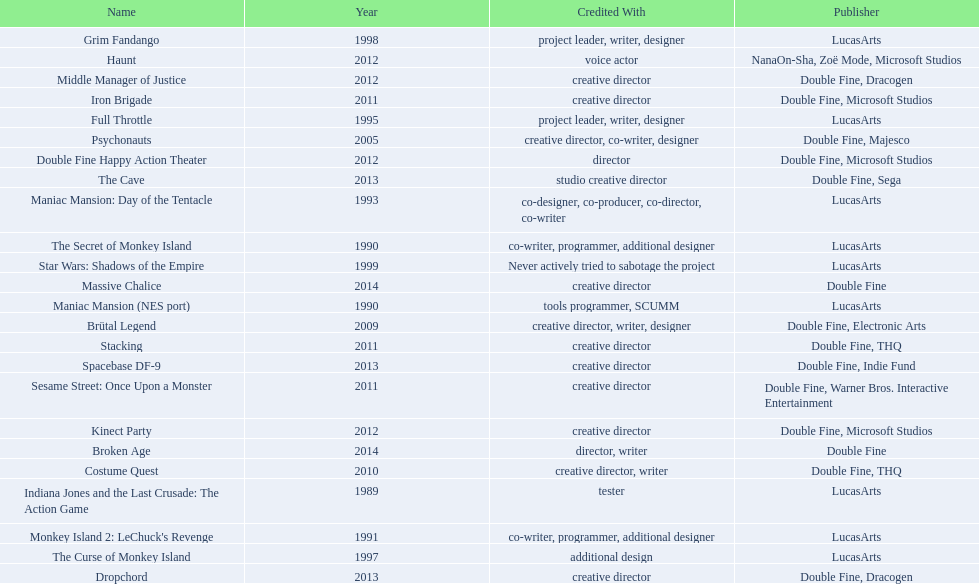What game name has tim schafer been involved with? Indiana Jones and the Last Crusade: The Action Game, Maniac Mansion (NES port), The Secret of Monkey Island, Monkey Island 2: LeChuck's Revenge, Maniac Mansion: Day of the Tentacle, Full Throttle, The Curse of Monkey Island, Grim Fandango, Star Wars: Shadows of the Empire, Psychonauts, Brütal Legend, Costume Quest, Stacking, Iron Brigade, Sesame Street: Once Upon a Monster, Haunt, Double Fine Happy Action Theater, Middle Manager of Justice, Kinect Party, The Cave, Dropchord, Spacebase DF-9, Broken Age, Massive Chalice. Which game has credit with just creative director? Creative director, creative director, creative director, creative director, creative director, creative director, creative director, creative director. Which games have the above and warner bros. interactive entertainment as publisher? Sesame Street: Once Upon a Monster. 